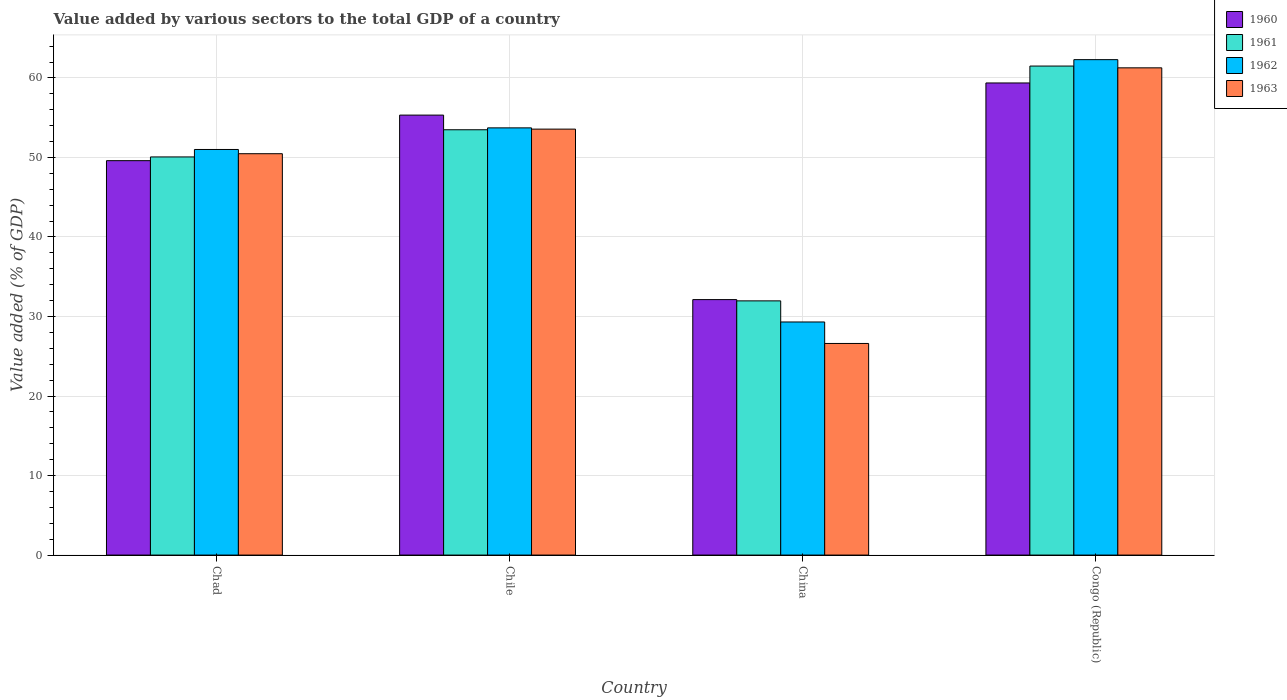How many different coloured bars are there?
Ensure brevity in your answer.  4. How many groups of bars are there?
Give a very brief answer. 4. How many bars are there on the 1st tick from the left?
Your answer should be very brief. 4. How many bars are there on the 1st tick from the right?
Provide a short and direct response. 4. What is the label of the 1st group of bars from the left?
Your answer should be compact. Chad. In how many cases, is the number of bars for a given country not equal to the number of legend labels?
Offer a terse response. 0. What is the value added by various sectors to the total GDP in 1960 in China?
Your answer should be very brief. 32.13. Across all countries, what is the maximum value added by various sectors to the total GDP in 1962?
Offer a terse response. 62.3. Across all countries, what is the minimum value added by various sectors to the total GDP in 1962?
Your answer should be very brief. 29.31. In which country was the value added by various sectors to the total GDP in 1962 maximum?
Ensure brevity in your answer.  Congo (Republic). What is the total value added by various sectors to the total GDP in 1963 in the graph?
Make the answer very short. 191.93. What is the difference between the value added by various sectors to the total GDP in 1961 in Chad and that in Chile?
Give a very brief answer. -3.42. What is the difference between the value added by various sectors to the total GDP in 1961 in Chile and the value added by various sectors to the total GDP in 1962 in Congo (Republic)?
Your answer should be very brief. -8.82. What is the average value added by various sectors to the total GDP in 1960 per country?
Ensure brevity in your answer.  49.11. What is the difference between the value added by various sectors to the total GDP of/in 1961 and value added by various sectors to the total GDP of/in 1963 in Chile?
Your response must be concise. -0.08. In how many countries, is the value added by various sectors to the total GDP in 1963 greater than 18 %?
Your answer should be very brief. 4. What is the ratio of the value added by various sectors to the total GDP in 1960 in Chile to that in China?
Give a very brief answer. 1.72. What is the difference between the highest and the second highest value added by various sectors to the total GDP in 1961?
Make the answer very short. -3.42. What is the difference between the highest and the lowest value added by various sectors to the total GDP in 1961?
Offer a very short reply. 29.53. In how many countries, is the value added by various sectors to the total GDP in 1961 greater than the average value added by various sectors to the total GDP in 1961 taken over all countries?
Your answer should be compact. 3. Is the sum of the value added by various sectors to the total GDP in 1960 in Chile and Congo (Republic) greater than the maximum value added by various sectors to the total GDP in 1963 across all countries?
Keep it short and to the point. Yes. Is it the case that in every country, the sum of the value added by various sectors to the total GDP in 1961 and value added by various sectors to the total GDP in 1960 is greater than the value added by various sectors to the total GDP in 1963?
Your response must be concise. Yes. How many bars are there?
Your response must be concise. 16. Are all the bars in the graph horizontal?
Your answer should be compact. No. Are the values on the major ticks of Y-axis written in scientific E-notation?
Give a very brief answer. No. Does the graph contain grids?
Make the answer very short. Yes. Where does the legend appear in the graph?
Give a very brief answer. Top right. How many legend labels are there?
Make the answer very short. 4. How are the legend labels stacked?
Provide a succinct answer. Vertical. What is the title of the graph?
Ensure brevity in your answer.  Value added by various sectors to the total GDP of a country. Does "1986" appear as one of the legend labels in the graph?
Provide a short and direct response. No. What is the label or title of the Y-axis?
Your response must be concise. Value added (% of GDP). What is the Value added (% of GDP) of 1960 in Chad?
Provide a short and direct response. 49.6. What is the Value added (% of GDP) in 1961 in Chad?
Provide a short and direct response. 50.07. What is the Value added (% of GDP) in 1962 in Chad?
Your answer should be very brief. 51.01. What is the Value added (% of GDP) of 1963 in Chad?
Give a very brief answer. 50.47. What is the Value added (% of GDP) of 1960 in Chile?
Offer a very short reply. 55.33. What is the Value added (% of GDP) of 1961 in Chile?
Ensure brevity in your answer.  53.49. What is the Value added (% of GDP) of 1962 in Chile?
Offer a terse response. 53.72. What is the Value added (% of GDP) in 1963 in Chile?
Keep it short and to the point. 53.57. What is the Value added (% of GDP) of 1960 in China?
Make the answer very short. 32.13. What is the Value added (% of GDP) of 1961 in China?
Offer a terse response. 31.97. What is the Value added (% of GDP) in 1962 in China?
Provide a succinct answer. 29.31. What is the Value added (% of GDP) of 1963 in China?
Keep it short and to the point. 26.61. What is the Value added (% of GDP) of 1960 in Congo (Republic)?
Provide a short and direct response. 59.37. What is the Value added (% of GDP) in 1961 in Congo (Republic)?
Your answer should be compact. 61.5. What is the Value added (% of GDP) of 1962 in Congo (Republic)?
Make the answer very short. 62.3. What is the Value added (% of GDP) in 1963 in Congo (Republic)?
Offer a terse response. 61.27. Across all countries, what is the maximum Value added (% of GDP) in 1960?
Make the answer very short. 59.37. Across all countries, what is the maximum Value added (% of GDP) of 1961?
Give a very brief answer. 61.5. Across all countries, what is the maximum Value added (% of GDP) in 1962?
Keep it short and to the point. 62.3. Across all countries, what is the maximum Value added (% of GDP) of 1963?
Provide a succinct answer. 61.27. Across all countries, what is the minimum Value added (% of GDP) in 1960?
Keep it short and to the point. 32.13. Across all countries, what is the minimum Value added (% of GDP) of 1961?
Your answer should be very brief. 31.97. Across all countries, what is the minimum Value added (% of GDP) of 1962?
Provide a succinct answer. 29.31. Across all countries, what is the minimum Value added (% of GDP) in 1963?
Ensure brevity in your answer.  26.61. What is the total Value added (% of GDP) of 1960 in the graph?
Your response must be concise. 196.43. What is the total Value added (% of GDP) in 1961 in the graph?
Your answer should be very brief. 197.02. What is the total Value added (% of GDP) in 1962 in the graph?
Your response must be concise. 196.35. What is the total Value added (% of GDP) of 1963 in the graph?
Offer a terse response. 191.93. What is the difference between the Value added (% of GDP) in 1960 in Chad and that in Chile?
Your answer should be compact. -5.73. What is the difference between the Value added (% of GDP) in 1961 in Chad and that in Chile?
Give a very brief answer. -3.42. What is the difference between the Value added (% of GDP) of 1962 in Chad and that in Chile?
Provide a short and direct response. -2.72. What is the difference between the Value added (% of GDP) in 1963 in Chad and that in Chile?
Give a very brief answer. -3.09. What is the difference between the Value added (% of GDP) in 1960 in Chad and that in China?
Provide a short and direct response. 17.47. What is the difference between the Value added (% of GDP) in 1961 in Chad and that in China?
Your answer should be compact. 18.1. What is the difference between the Value added (% of GDP) of 1962 in Chad and that in China?
Make the answer very short. 21.69. What is the difference between the Value added (% of GDP) in 1963 in Chad and that in China?
Your answer should be very brief. 23.86. What is the difference between the Value added (% of GDP) in 1960 in Chad and that in Congo (Republic)?
Your answer should be compact. -9.77. What is the difference between the Value added (% of GDP) in 1961 in Chad and that in Congo (Republic)?
Give a very brief answer. -11.43. What is the difference between the Value added (% of GDP) of 1962 in Chad and that in Congo (Republic)?
Offer a terse response. -11.3. What is the difference between the Value added (% of GDP) in 1963 in Chad and that in Congo (Republic)?
Provide a short and direct response. -10.8. What is the difference between the Value added (% of GDP) of 1960 in Chile and that in China?
Provide a short and direct response. 23.2. What is the difference between the Value added (% of GDP) of 1961 in Chile and that in China?
Provide a short and direct response. 21.52. What is the difference between the Value added (% of GDP) of 1962 in Chile and that in China?
Make the answer very short. 24.41. What is the difference between the Value added (% of GDP) of 1963 in Chile and that in China?
Give a very brief answer. 26.96. What is the difference between the Value added (% of GDP) in 1960 in Chile and that in Congo (Republic)?
Ensure brevity in your answer.  -4.04. What is the difference between the Value added (% of GDP) in 1961 in Chile and that in Congo (Republic)?
Your answer should be compact. -8.01. What is the difference between the Value added (% of GDP) of 1962 in Chile and that in Congo (Republic)?
Provide a short and direct response. -8.58. What is the difference between the Value added (% of GDP) in 1963 in Chile and that in Congo (Republic)?
Provide a succinct answer. -7.71. What is the difference between the Value added (% of GDP) in 1960 in China and that in Congo (Republic)?
Keep it short and to the point. -27.24. What is the difference between the Value added (% of GDP) of 1961 in China and that in Congo (Republic)?
Provide a short and direct response. -29.53. What is the difference between the Value added (% of GDP) in 1962 in China and that in Congo (Republic)?
Give a very brief answer. -32.99. What is the difference between the Value added (% of GDP) in 1963 in China and that in Congo (Republic)?
Your answer should be very brief. -34.66. What is the difference between the Value added (% of GDP) in 1960 in Chad and the Value added (% of GDP) in 1961 in Chile?
Offer a terse response. -3.89. What is the difference between the Value added (% of GDP) of 1960 in Chad and the Value added (% of GDP) of 1962 in Chile?
Provide a succinct answer. -4.13. What is the difference between the Value added (% of GDP) in 1960 in Chad and the Value added (% of GDP) in 1963 in Chile?
Give a very brief answer. -3.97. What is the difference between the Value added (% of GDP) in 1961 in Chad and the Value added (% of GDP) in 1962 in Chile?
Ensure brevity in your answer.  -3.66. What is the difference between the Value added (% of GDP) in 1961 in Chad and the Value added (% of GDP) in 1963 in Chile?
Give a very brief answer. -3.5. What is the difference between the Value added (% of GDP) in 1962 in Chad and the Value added (% of GDP) in 1963 in Chile?
Your response must be concise. -2.56. What is the difference between the Value added (% of GDP) of 1960 in Chad and the Value added (% of GDP) of 1961 in China?
Provide a succinct answer. 17.63. What is the difference between the Value added (% of GDP) in 1960 in Chad and the Value added (% of GDP) in 1962 in China?
Offer a terse response. 20.29. What is the difference between the Value added (% of GDP) of 1960 in Chad and the Value added (% of GDP) of 1963 in China?
Give a very brief answer. 22.99. What is the difference between the Value added (% of GDP) in 1961 in Chad and the Value added (% of GDP) in 1962 in China?
Give a very brief answer. 20.76. What is the difference between the Value added (% of GDP) of 1961 in Chad and the Value added (% of GDP) of 1963 in China?
Ensure brevity in your answer.  23.46. What is the difference between the Value added (% of GDP) of 1962 in Chad and the Value added (% of GDP) of 1963 in China?
Make the answer very short. 24.39. What is the difference between the Value added (% of GDP) of 1960 in Chad and the Value added (% of GDP) of 1961 in Congo (Republic)?
Provide a short and direct response. -11.9. What is the difference between the Value added (% of GDP) in 1960 in Chad and the Value added (% of GDP) in 1962 in Congo (Republic)?
Ensure brevity in your answer.  -12.7. What is the difference between the Value added (% of GDP) in 1960 in Chad and the Value added (% of GDP) in 1963 in Congo (Republic)?
Your answer should be very brief. -11.67. What is the difference between the Value added (% of GDP) in 1961 in Chad and the Value added (% of GDP) in 1962 in Congo (Republic)?
Your answer should be compact. -12.23. What is the difference between the Value added (% of GDP) of 1961 in Chad and the Value added (% of GDP) of 1963 in Congo (Republic)?
Your response must be concise. -11.2. What is the difference between the Value added (% of GDP) in 1962 in Chad and the Value added (% of GDP) in 1963 in Congo (Republic)?
Provide a short and direct response. -10.27. What is the difference between the Value added (% of GDP) in 1960 in Chile and the Value added (% of GDP) in 1961 in China?
Your answer should be compact. 23.36. What is the difference between the Value added (% of GDP) of 1960 in Chile and the Value added (% of GDP) of 1962 in China?
Your answer should be very brief. 26.02. What is the difference between the Value added (% of GDP) of 1960 in Chile and the Value added (% of GDP) of 1963 in China?
Keep it short and to the point. 28.72. What is the difference between the Value added (% of GDP) in 1961 in Chile and the Value added (% of GDP) in 1962 in China?
Ensure brevity in your answer.  24.17. What is the difference between the Value added (% of GDP) of 1961 in Chile and the Value added (% of GDP) of 1963 in China?
Your answer should be compact. 26.87. What is the difference between the Value added (% of GDP) in 1962 in Chile and the Value added (% of GDP) in 1963 in China?
Provide a succinct answer. 27.11. What is the difference between the Value added (% of GDP) in 1960 in Chile and the Value added (% of GDP) in 1961 in Congo (Republic)?
Provide a short and direct response. -6.17. What is the difference between the Value added (% of GDP) of 1960 in Chile and the Value added (% of GDP) of 1962 in Congo (Republic)?
Make the answer very short. -6.97. What is the difference between the Value added (% of GDP) of 1960 in Chile and the Value added (% of GDP) of 1963 in Congo (Republic)?
Make the answer very short. -5.94. What is the difference between the Value added (% of GDP) of 1961 in Chile and the Value added (% of GDP) of 1962 in Congo (Republic)?
Provide a succinct answer. -8.82. What is the difference between the Value added (% of GDP) of 1961 in Chile and the Value added (% of GDP) of 1963 in Congo (Republic)?
Your answer should be compact. -7.79. What is the difference between the Value added (% of GDP) in 1962 in Chile and the Value added (% of GDP) in 1963 in Congo (Republic)?
Keep it short and to the point. -7.55. What is the difference between the Value added (% of GDP) in 1960 in China and the Value added (% of GDP) in 1961 in Congo (Republic)?
Offer a terse response. -29.37. What is the difference between the Value added (% of GDP) in 1960 in China and the Value added (% of GDP) in 1962 in Congo (Republic)?
Offer a terse response. -30.18. What is the difference between the Value added (% of GDP) of 1960 in China and the Value added (% of GDP) of 1963 in Congo (Republic)?
Your answer should be compact. -29.15. What is the difference between the Value added (% of GDP) of 1961 in China and the Value added (% of GDP) of 1962 in Congo (Republic)?
Make the answer very short. -30.34. What is the difference between the Value added (% of GDP) of 1961 in China and the Value added (% of GDP) of 1963 in Congo (Republic)?
Provide a succinct answer. -29.31. What is the difference between the Value added (% of GDP) of 1962 in China and the Value added (% of GDP) of 1963 in Congo (Republic)?
Provide a short and direct response. -31.96. What is the average Value added (% of GDP) in 1960 per country?
Your response must be concise. 49.11. What is the average Value added (% of GDP) of 1961 per country?
Give a very brief answer. 49.25. What is the average Value added (% of GDP) in 1962 per country?
Your answer should be very brief. 49.09. What is the average Value added (% of GDP) of 1963 per country?
Your answer should be very brief. 47.98. What is the difference between the Value added (% of GDP) in 1960 and Value added (% of GDP) in 1961 in Chad?
Keep it short and to the point. -0.47. What is the difference between the Value added (% of GDP) of 1960 and Value added (% of GDP) of 1962 in Chad?
Make the answer very short. -1.41. What is the difference between the Value added (% of GDP) in 1960 and Value added (% of GDP) in 1963 in Chad?
Your answer should be compact. -0.88. What is the difference between the Value added (% of GDP) of 1961 and Value added (% of GDP) of 1962 in Chad?
Offer a very short reply. -0.94. What is the difference between the Value added (% of GDP) in 1961 and Value added (% of GDP) in 1963 in Chad?
Offer a very short reply. -0.41. What is the difference between the Value added (% of GDP) of 1962 and Value added (% of GDP) of 1963 in Chad?
Your answer should be very brief. 0.53. What is the difference between the Value added (% of GDP) of 1960 and Value added (% of GDP) of 1961 in Chile?
Make the answer very short. 1.84. What is the difference between the Value added (% of GDP) of 1960 and Value added (% of GDP) of 1962 in Chile?
Offer a terse response. 1.6. What is the difference between the Value added (% of GDP) of 1960 and Value added (% of GDP) of 1963 in Chile?
Offer a very short reply. 1.76. What is the difference between the Value added (% of GDP) in 1961 and Value added (% of GDP) in 1962 in Chile?
Offer a very short reply. -0.24. What is the difference between the Value added (% of GDP) of 1961 and Value added (% of GDP) of 1963 in Chile?
Your response must be concise. -0.08. What is the difference between the Value added (% of GDP) in 1962 and Value added (% of GDP) in 1963 in Chile?
Offer a terse response. 0.16. What is the difference between the Value added (% of GDP) of 1960 and Value added (% of GDP) of 1961 in China?
Give a very brief answer. 0.16. What is the difference between the Value added (% of GDP) of 1960 and Value added (% of GDP) of 1962 in China?
Keep it short and to the point. 2.81. What is the difference between the Value added (% of GDP) of 1960 and Value added (% of GDP) of 1963 in China?
Offer a very short reply. 5.52. What is the difference between the Value added (% of GDP) in 1961 and Value added (% of GDP) in 1962 in China?
Give a very brief answer. 2.65. What is the difference between the Value added (% of GDP) of 1961 and Value added (% of GDP) of 1963 in China?
Give a very brief answer. 5.36. What is the difference between the Value added (% of GDP) of 1962 and Value added (% of GDP) of 1963 in China?
Offer a terse response. 2.7. What is the difference between the Value added (% of GDP) of 1960 and Value added (% of GDP) of 1961 in Congo (Republic)?
Provide a succinct answer. -2.13. What is the difference between the Value added (% of GDP) of 1960 and Value added (% of GDP) of 1962 in Congo (Republic)?
Provide a succinct answer. -2.93. What is the difference between the Value added (% of GDP) in 1960 and Value added (% of GDP) in 1963 in Congo (Republic)?
Your answer should be compact. -1.9. What is the difference between the Value added (% of GDP) of 1961 and Value added (% of GDP) of 1962 in Congo (Republic)?
Keep it short and to the point. -0.81. What is the difference between the Value added (% of GDP) in 1961 and Value added (% of GDP) in 1963 in Congo (Republic)?
Give a very brief answer. 0.22. What is the difference between the Value added (% of GDP) of 1962 and Value added (% of GDP) of 1963 in Congo (Republic)?
Provide a succinct answer. 1.03. What is the ratio of the Value added (% of GDP) in 1960 in Chad to that in Chile?
Provide a succinct answer. 0.9. What is the ratio of the Value added (% of GDP) in 1961 in Chad to that in Chile?
Keep it short and to the point. 0.94. What is the ratio of the Value added (% of GDP) of 1962 in Chad to that in Chile?
Give a very brief answer. 0.95. What is the ratio of the Value added (% of GDP) in 1963 in Chad to that in Chile?
Give a very brief answer. 0.94. What is the ratio of the Value added (% of GDP) in 1960 in Chad to that in China?
Ensure brevity in your answer.  1.54. What is the ratio of the Value added (% of GDP) in 1961 in Chad to that in China?
Your answer should be very brief. 1.57. What is the ratio of the Value added (% of GDP) of 1962 in Chad to that in China?
Your response must be concise. 1.74. What is the ratio of the Value added (% of GDP) in 1963 in Chad to that in China?
Ensure brevity in your answer.  1.9. What is the ratio of the Value added (% of GDP) in 1960 in Chad to that in Congo (Republic)?
Offer a terse response. 0.84. What is the ratio of the Value added (% of GDP) of 1961 in Chad to that in Congo (Republic)?
Provide a succinct answer. 0.81. What is the ratio of the Value added (% of GDP) of 1962 in Chad to that in Congo (Republic)?
Make the answer very short. 0.82. What is the ratio of the Value added (% of GDP) in 1963 in Chad to that in Congo (Republic)?
Ensure brevity in your answer.  0.82. What is the ratio of the Value added (% of GDP) in 1960 in Chile to that in China?
Your answer should be very brief. 1.72. What is the ratio of the Value added (% of GDP) of 1961 in Chile to that in China?
Keep it short and to the point. 1.67. What is the ratio of the Value added (% of GDP) of 1962 in Chile to that in China?
Provide a short and direct response. 1.83. What is the ratio of the Value added (% of GDP) of 1963 in Chile to that in China?
Your answer should be very brief. 2.01. What is the ratio of the Value added (% of GDP) of 1960 in Chile to that in Congo (Republic)?
Your answer should be very brief. 0.93. What is the ratio of the Value added (% of GDP) of 1961 in Chile to that in Congo (Republic)?
Provide a short and direct response. 0.87. What is the ratio of the Value added (% of GDP) in 1962 in Chile to that in Congo (Republic)?
Offer a very short reply. 0.86. What is the ratio of the Value added (% of GDP) in 1963 in Chile to that in Congo (Republic)?
Offer a terse response. 0.87. What is the ratio of the Value added (% of GDP) in 1960 in China to that in Congo (Republic)?
Make the answer very short. 0.54. What is the ratio of the Value added (% of GDP) in 1961 in China to that in Congo (Republic)?
Your answer should be very brief. 0.52. What is the ratio of the Value added (% of GDP) of 1962 in China to that in Congo (Republic)?
Your response must be concise. 0.47. What is the ratio of the Value added (% of GDP) of 1963 in China to that in Congo (Republic)?
Ensure brevity in your answer.  0.43. What is the difference between the highest and the second highest Value added (% of GDP) of 1960?
Your answer should be compact. 4.04. What is the difference between the highest and the second highest Value added (% of GDP) in 1961?
Offer a very short reply. 8.01. What is the difference between the highest and the second highest Value added (% of GDP) of 1962?
Offer a very short reply. 8.58. What is the difference between the highest and the second highest Value added (% of GDP) of 1963?
Keep it short and to the point. 7.71. What is the difference between the highest and the lowest Value added (% of GDP) of 1960?
Give a very brief answer. 27.24. What is the difference between the highest and the lowest Value added (% of GDP) of 1961?
Make the answer very short. 29.53. What is the difference between the highest and the lowest Value added (% of GDP) of 1962?
Provide a short and direct response. 32.99. What is the difference between the highest and the lowest Value added (% of GDP) of 1963?
Your answer should be compact. 34.66. 